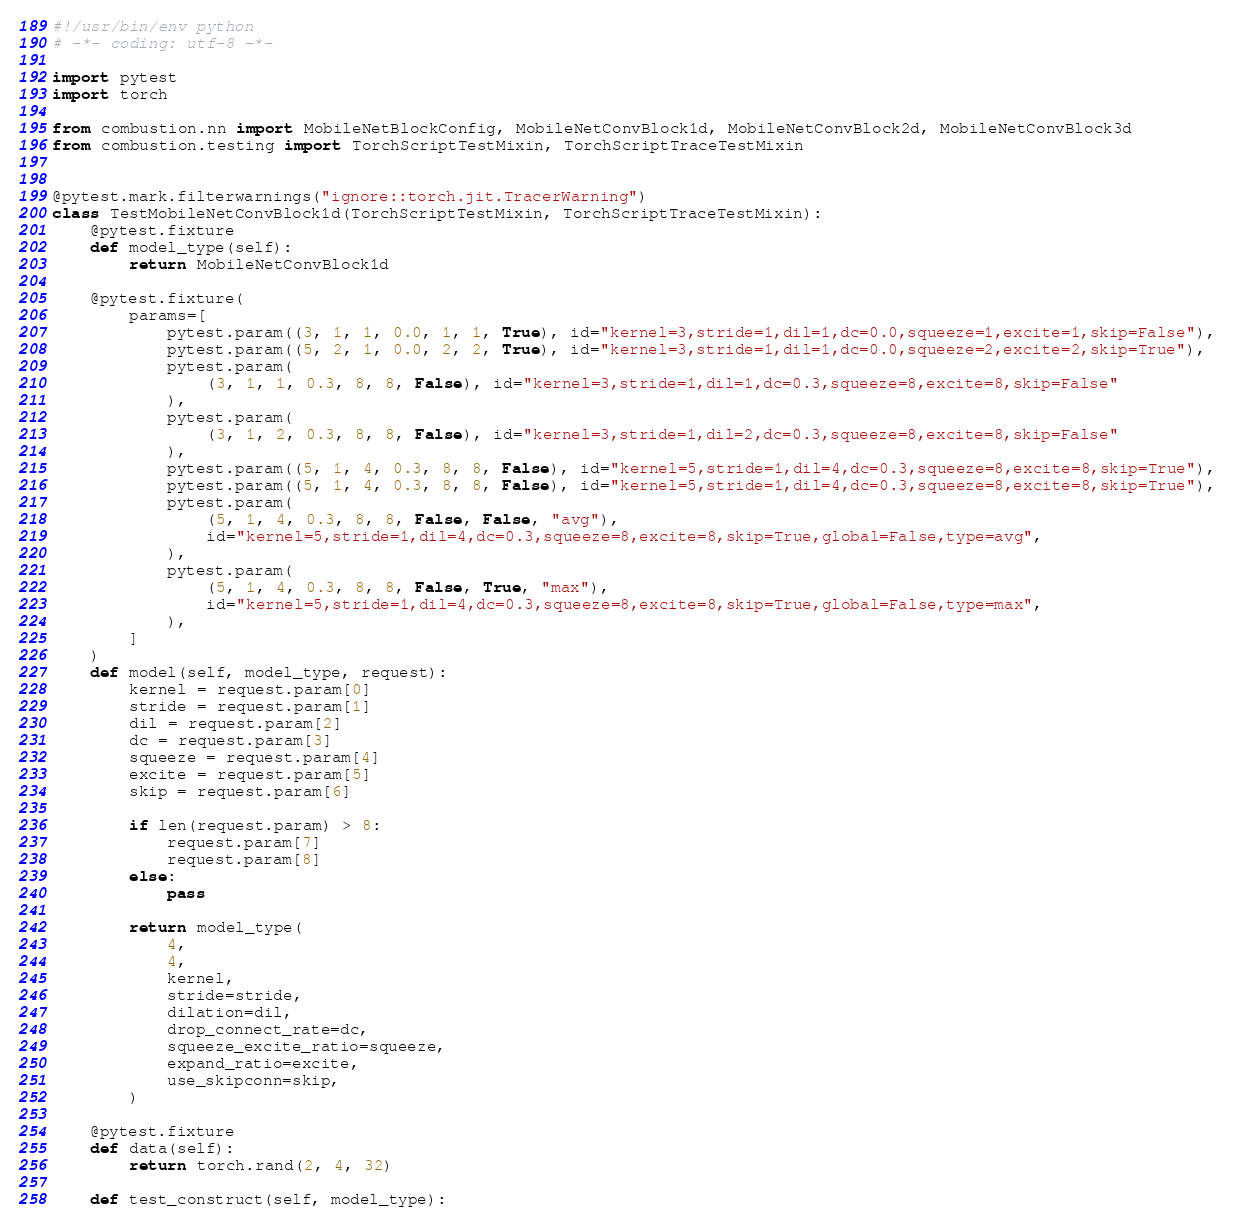<code> <loc_0><loc_0><loc_500><loc_500><_Python_>#!/usr/bin/env python
# -*- coding: utf-8 -*-

import pytest
import torch

from combustion.nn import MobileNetBlockConfig, MobileNetConvBlock1d, MobileNetConvBlock2d, MobileNetConvBlock3d
from combustion.testing import TorchScriptTestMixin, TorchScriptTraceTestMixin


@pytest.mark.filterwarnings("ignore::torch.jit.TracerWarning")
class TestMobileNetConvBlock1d(TorchScriptTestMixin, TorchScriptTraceTestMixin):
    @pytest.fixture
    def model_type(self):
        return MobileNetConvBlock1d

    @pytest.fixture(
        params=[
            pytest.param((3, 1, 1, 0.0, 1, 1, True), id="kernel=3,stride=1,dil=1,dc=0.0,squeeze=1,excite=1,skip=False"),
            pytest.param((5, 2, 1, 0.0, 2, 2, True), id="kernel=3,stride=1,dil=1,dc=0.0,squeeze=2,excite=2,skip=True"),
            pytest.param(
                (3, 1, 1, 0.3, 8, 8, False), id="kernel=3,stride=1,dil=1,dc=0.3,squeeze=8,excite=8,skip=False"
            ),
            pytest.param(
                (3, 1, 2, 0.3, 8, 8, False), id="kernel=3,stride=1,dil=2,dc=0.3,squeeze=8,excite=8,skip=False"
            ),
            pytest.param((5, 1, 4, 0.3, 8, 8, False), id="kernel=5,stride=1,dil=4,dc=0.3,squeeze=8,excite=8,skip=True"),
            pytest.param((5, 1, 4, 0.3, 8, 8, False), id="kernel=5,stride=1,dil=4,dc=0.3,squeeze=8,excite=8,skip=True"),
            pytest.param(
                (5, 1, 4, 0.3, 8, 8, False, False, "avg"),
                id="kernel=5,stride=1,dil=4,dc=0.3,squeeze=8,excite=8,skip=True,global=False,type=avg",
            ),
            pytest.param(
                (5, 1, 4, 0.3, 8, 8, False, True, "max"),
                id="kernel=5,stride=1,dil=4,dc=0.3,squeeze=8,excite=8,skip=True,global=False,type=max",
            ),
        ]
    )
    def model(self, model_type, request):
        kernel = request.param[0]
        stride = request.param[1]
        dil = request.param[2]
        dc = request.param[3]
        squeeze = request.param[4]
        excite = request.param[5]
        skip = request.param[6]

        if len(request.param) > 8:
            request.param[7]
            request.param[8]
        else:
            pass

        return model_type(
            4,
            4,
            kernel,
            stride=stride,
            dilation=dil,
            drop_connect_rate=dc,
            squeeze_excite_ratio=squeeze,
            expand_ratio=excite,
            use_skipconn=skip,
        )

    @pytest.fixture
    def data(self):
        return torch.rand(2, 4, 32)

    def test_construct(self, model_type):</code> 